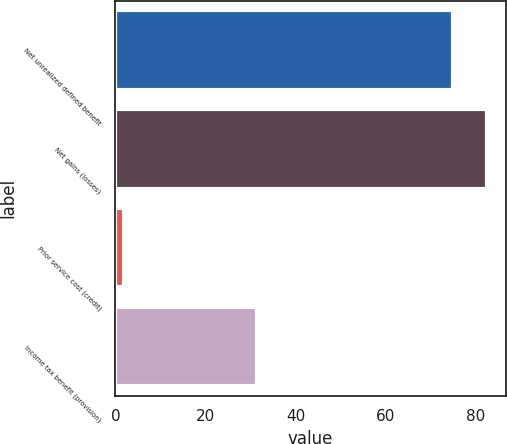Convert chart. <chart><loc_0><loc_0><loc_500><loc_500><bar_chart><fcel>Net unrealized defined benefit<fcel>Net gains (losses)<fcel>Prior service cost (credit)<fcel>Income tax benefit (provision)<nl><fcel>75<fcel>82.5<fcel>2<fcel>31.5<nl></chart> 